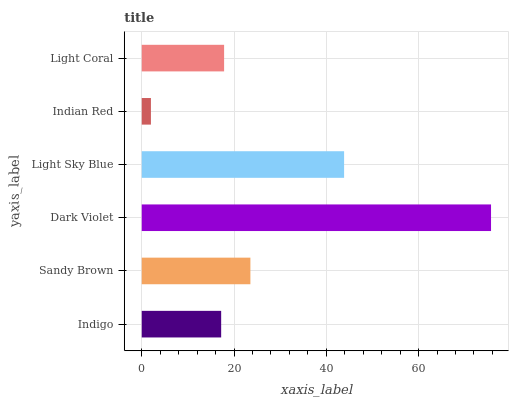Is Indian Red the minimum?
Answer yes or no. Yes. Is Dark Violet the maximum?
Answer yes or no. Yes. Is Sandy Brown the minimum?
Answer yes or no. No. Is Sandy Brown the maximum?
Answer yes or no. No. Is Sandy Brown greater than Indigo?
Answer yes or no. Yes. Is Indigo less than Sandy Brown?
Answer yes or no. Yes. Is Indigo greater than Sandy Brown?
Answer yes or no. No. Is Sandy Brown less than Indigo?
Answer yes or no. No. Is Sandy Brown the high median?
Answer yes or no. Yes. Is Light Coral the low median?
Answer yes or no. Yes. Is Light Coral the high median?
Answer yes or no. No. Is Dark Violet the low median?
Answer yes or no. No. 